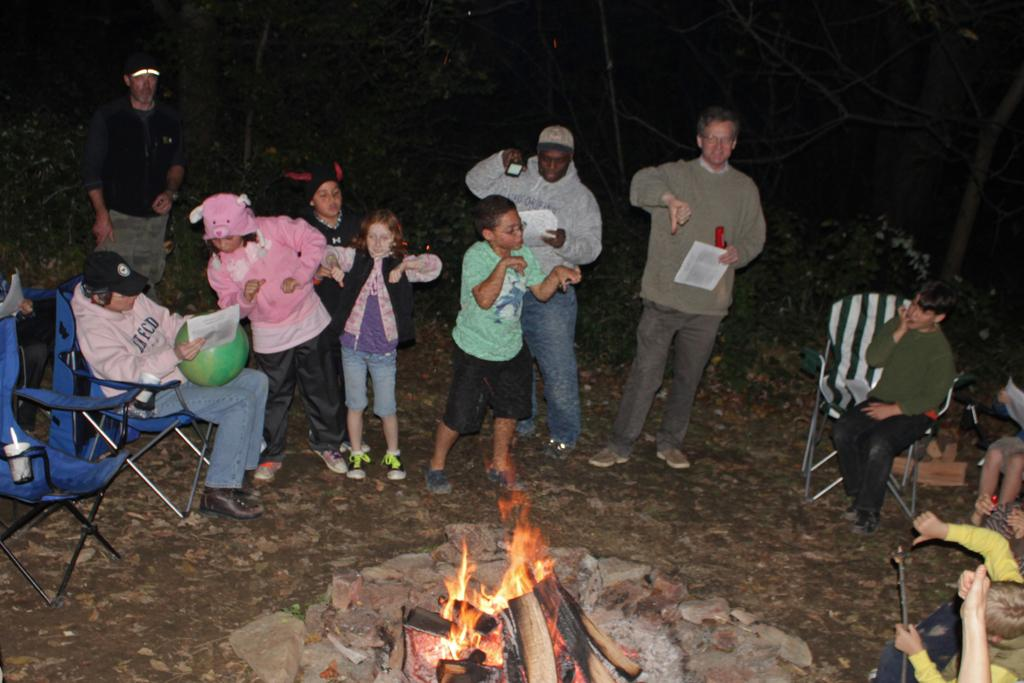What are the persons in the image doing? The persons in the image are sitting on chairs and standing on the ground. What objects can be seen in the image besides the persons? Papers and stones are visible in the image. What activity is taking place in the image? There is a camp fire in the image. What can be seen in the background of the image? Trees are present in the background of the image. What type of baseball game is being played in the image? There is no baseball game present in the image; it features persons sitting and standing, papers, stones, a camp fire, and trees in the background. 